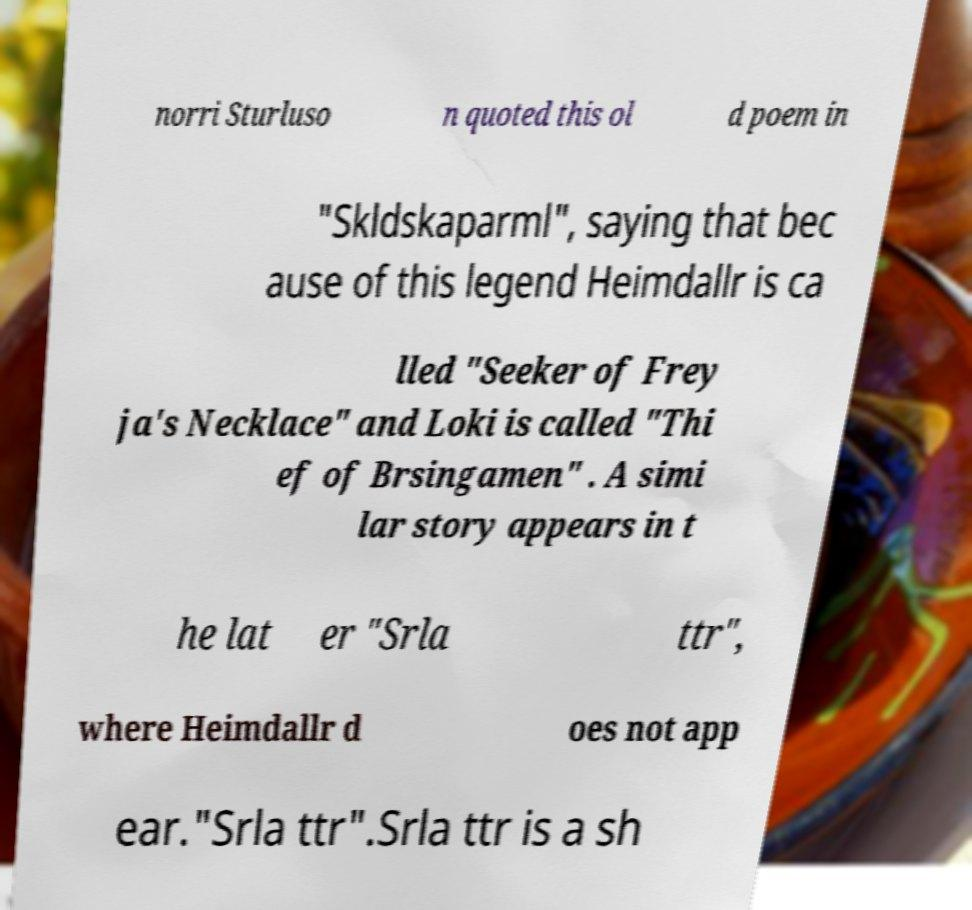I need the written content from this picture converted into text. Can you do that? norri Sturluso n quoted this ol d poem in "Skldskaparml", saying that bec ause of this legend Heimdallr is ca lled "Seeker of Frey ja's Necklace" and Loki is called "Thi ef of Brsingamen" . A simi lar story appears in t he lat er "Srla ttr", where Heimdallr d oes not app ear."Srla ttr".Srla ttr is a sh 